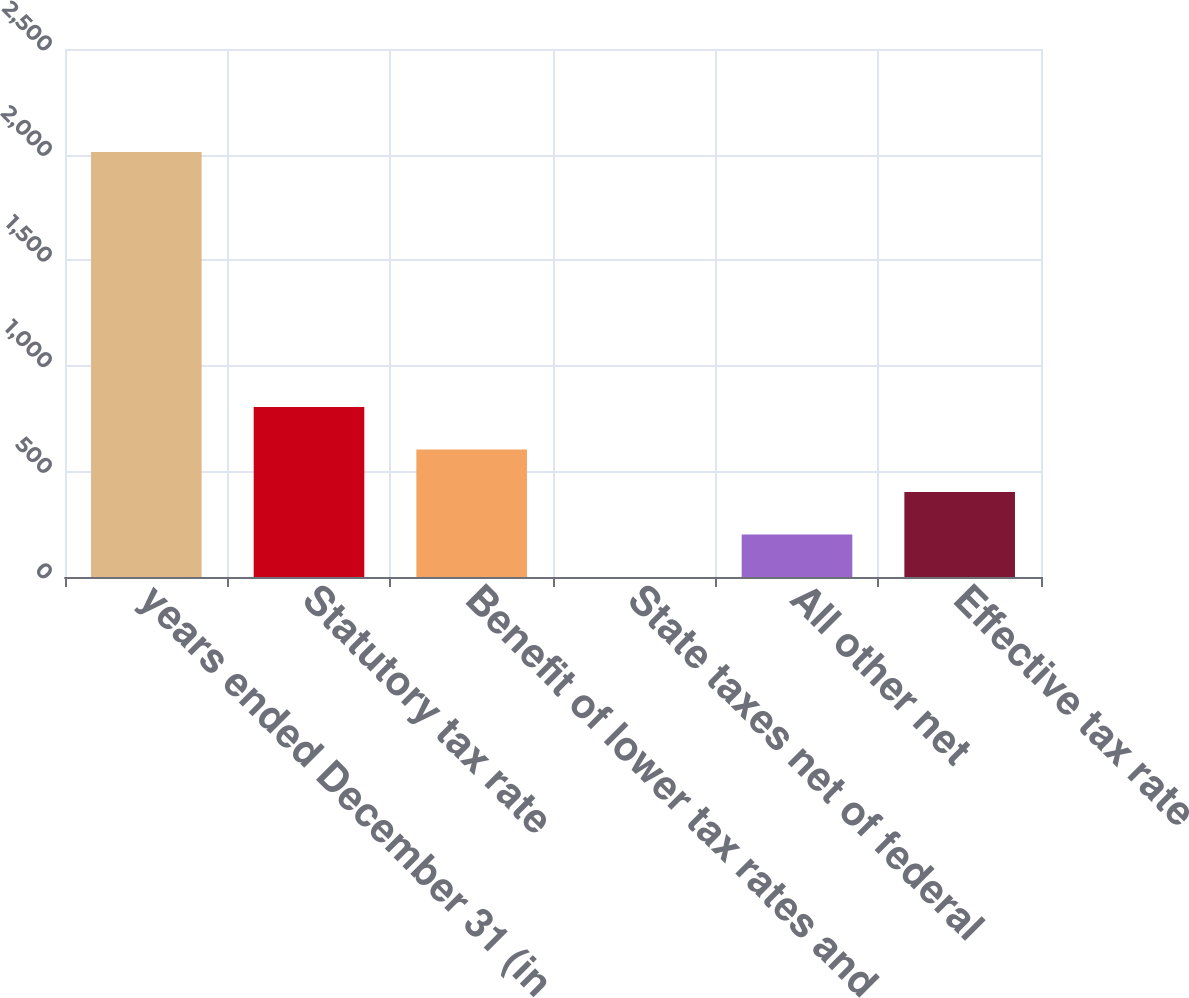Convert chart to OTSL. <chart><loc_0><loc_0><loc_500><loc_500><bar_chart><fcel>years ended December 31 (in<fcel>Statutory tax rate<fcel>Benefit of lower tax rates and<fcel>State taxes net of federal<fcel>All other net<fcel>Effective tax rate<nl><fcel>2012<fcel>804.86<fcel>603.67<fcel>0.1<fcel>201.29<fcel>402.48<nl></chart> 